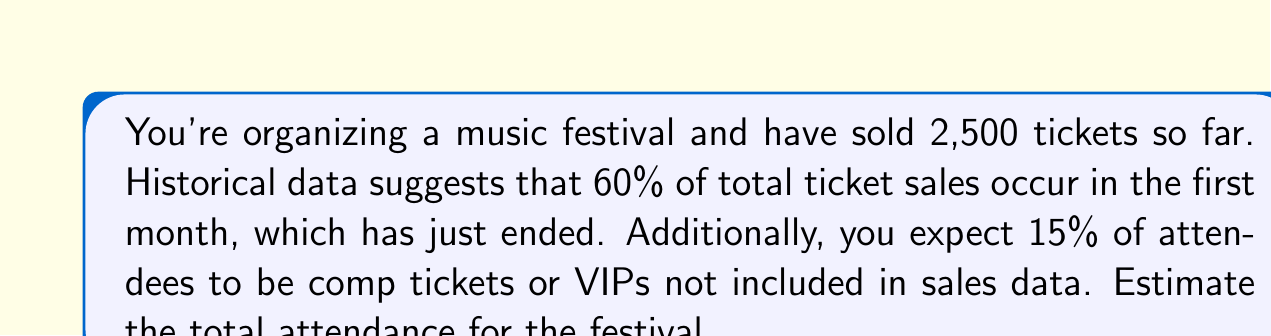Can you answer this question? Let's approach this step-by-step:

1) First, we need to estimate the total number of sold tickets based on the current sales:
   Let $x$ be the total number of sold tickets.
   We know that 2,500 tickets represent 60% of total sales.
   $$2500 = 0.60x$$

2) Solve for $x$:
   $$x = \frac{2500}{0.60} = 4166.67$$
   Round to the nearest whole number: 4,167 total sold tickets

3) Now, we need to account for the comp tickets and VIPs:
   These represent an additional 15% on top of the sold tickets.
   Let $y$ be the total attendance including comp tickets and VIPs.
   $$y = 4167 + (0.15 \times 4167)$$

4) Simplify:
   $$y = 4167 + 625.05$$
   $$y = 4792.05$$

5) Round to the nearest whole number for the final estimate:
   Total estimated attendance = 4,792 people
Answer: 4,792 attendees 